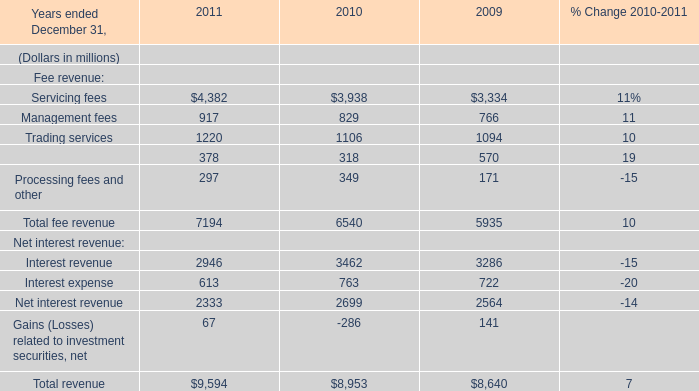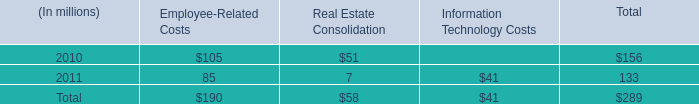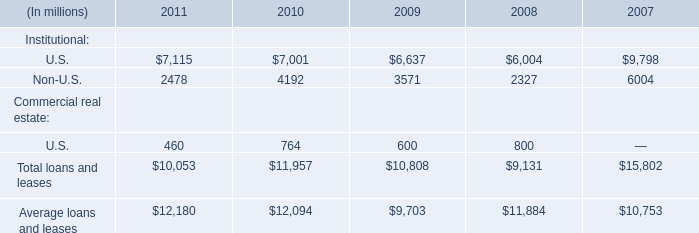what was the percent of the aggregate restructuring charges recorded in 2010 
Computations: (156 / 289)
Answer: 0.53979. 